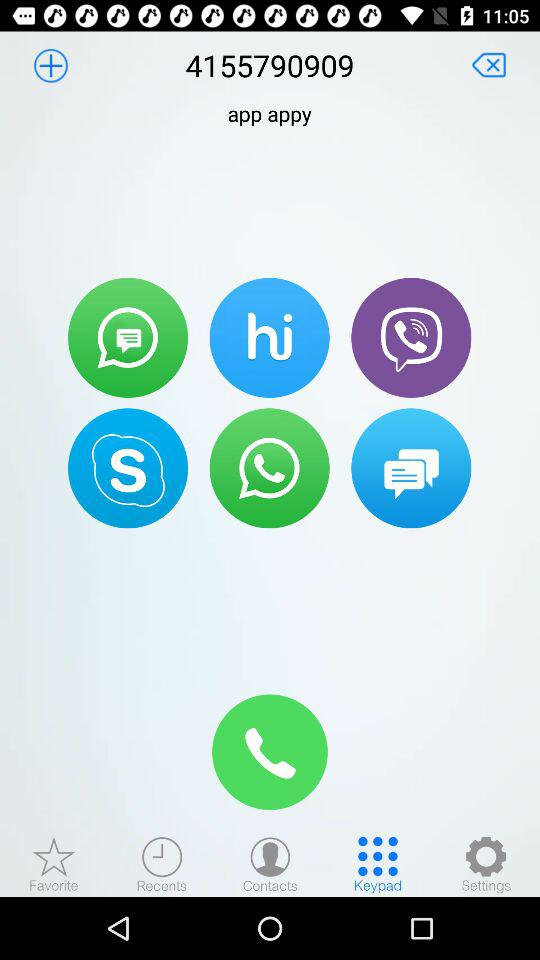What's the phone number? The phone number is 4155790909. 